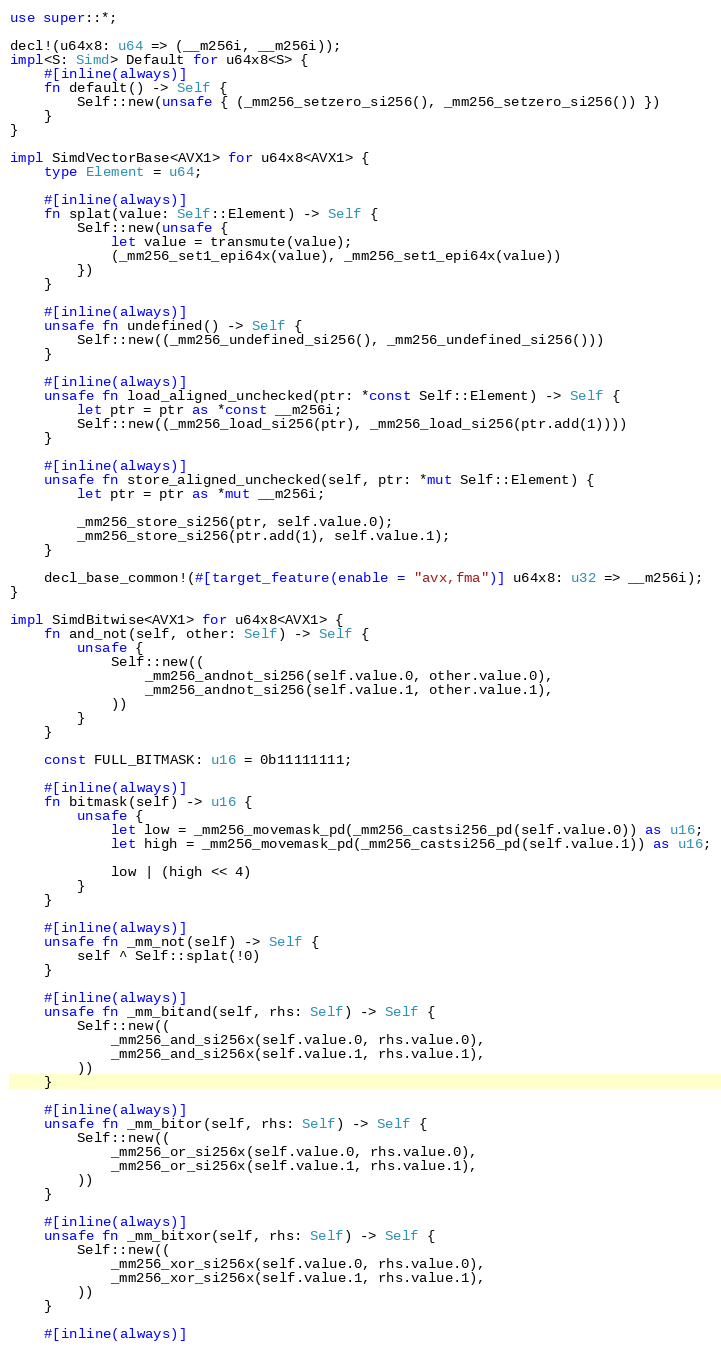<code> <loc_0><loc_0><loc_500><loc_500><_Rust_>use super::*;

decl!(u64x8: u64 => (__m256i, __m256i));
impl<S: Simd> Default for u64x8<S> {
    #[inline(always)]
    fn default() -> Self {
        Self::new(unsafe { (_mm256_setzero_si256(), _mm256_setzero_si256()) })
    }
}

impl SimdVectorBase<AVX1> for u64x8<AVX1> {
    type Element = u64;

    #[inline(always)]
    fn splat(value: Self::Element) -> Self {
        Self::new(unsafe {
            let value = transmute(value);
            (_mm256_set1_epi64x(value), _mm256_set1_epi64x(value))
        })
    }

    #[inline(always)]
    unsafe fn undefined() -> Self {
        Self::new((_mm256_undefined_si256(), _mm256_undefined_si256()))
    }

    #[inline(always)]
    unsafe fn load_aligned_unchecked(ptr: *const Self::Element) -> Self {
        let ptr = ptr as *const __m256i;
        Self::new((_mm256_load_si256(ptr), _mm256_load_si256(ptr.add(1))))
    }

    #[inline(always)]
    unsafe fn store_aligned_unchecked(self, ptr: *mut Self::Element) {
        let ptr = ptr as *mut __m256i;

        _mm256_store_si256(ptr, self.value.0);
        _mm256_store_si256(ptr.add(1), self.value.1);
    }

    decl_base_common!(#[target_feature(enable = "avx,fma")] u64x8: u32 => __m256i);
}

impl SimdBitwise<AVX1> for u64x8<AVX1> {
    fn and_not(self, other: Self) -> Self {
        unsafe {
            Self::new((
                _mm256_andnot_si256(self.value.0, other.value.0),
                _mm256_andnot_si256(self.value.1, other.value.1),
            ))
        }
    }

    const FULL_BITMASK: u16 = 0b11111111;

    #[inline(always)]
    fn bitmask(self) -> u16 {
        unsafe {
            let low = _mm256_movemask_pd(_mm256_castsi256_pd(self.value.0)) as u16;
            let high = _mm256_movemask_pd(_mm256_castsi256_pd(self.value.1)) as u16;

            low | (high << 4)
        }
    }

    #[inline(always)]
    unsafe fn _mm_not(self) -> Self {
        self ^ Self::splat(!0)
    }

    #[inline(always)]
    unsafe fn _mm_bitand(self, rhs: Self) -> Self {
        Self::new((
            _mm256_and_si256x(self.value.0, rhs.value.0),
            _mm256_and_si256x(self.value.1, rhs.value.1),
        ))
    }

    #[inline(always)]
    unsafe fn _mm_bitor(self, rhs: Self) -> Self {
        Self::new((
            _mm256_or_si256x(self.value.0, rhs.value.0),
            _mm256_or_si256x(self.value.1, rhs.value.1),
        ))
    }

    #[inline(always)]
    unsafe fn _mm_bitxor(self, rhs: Self) -> Self {
        Self::new((
            _mm256_xor_si256x(self.value.0, rhs.value.0),
            _mm256_xor_si256x(self.value.1, rhs.value.1),
        ))
    }

    #[inline(always)]</code> 